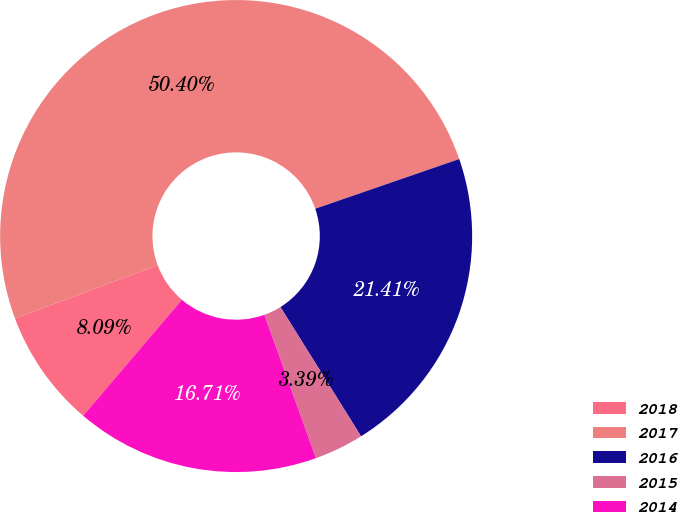Convert chart. <chart><loc_0><loc_0><loc_500><loc_500><pie_chart><fcel>2018<fcel>2017<fcel>2016<fcel>2015<fcel>2014<nl><fcel>8.09%<fcel>50.39%<fcel>21.41%<fcel>3.39%<fcel>16.71%<nl></chart> 